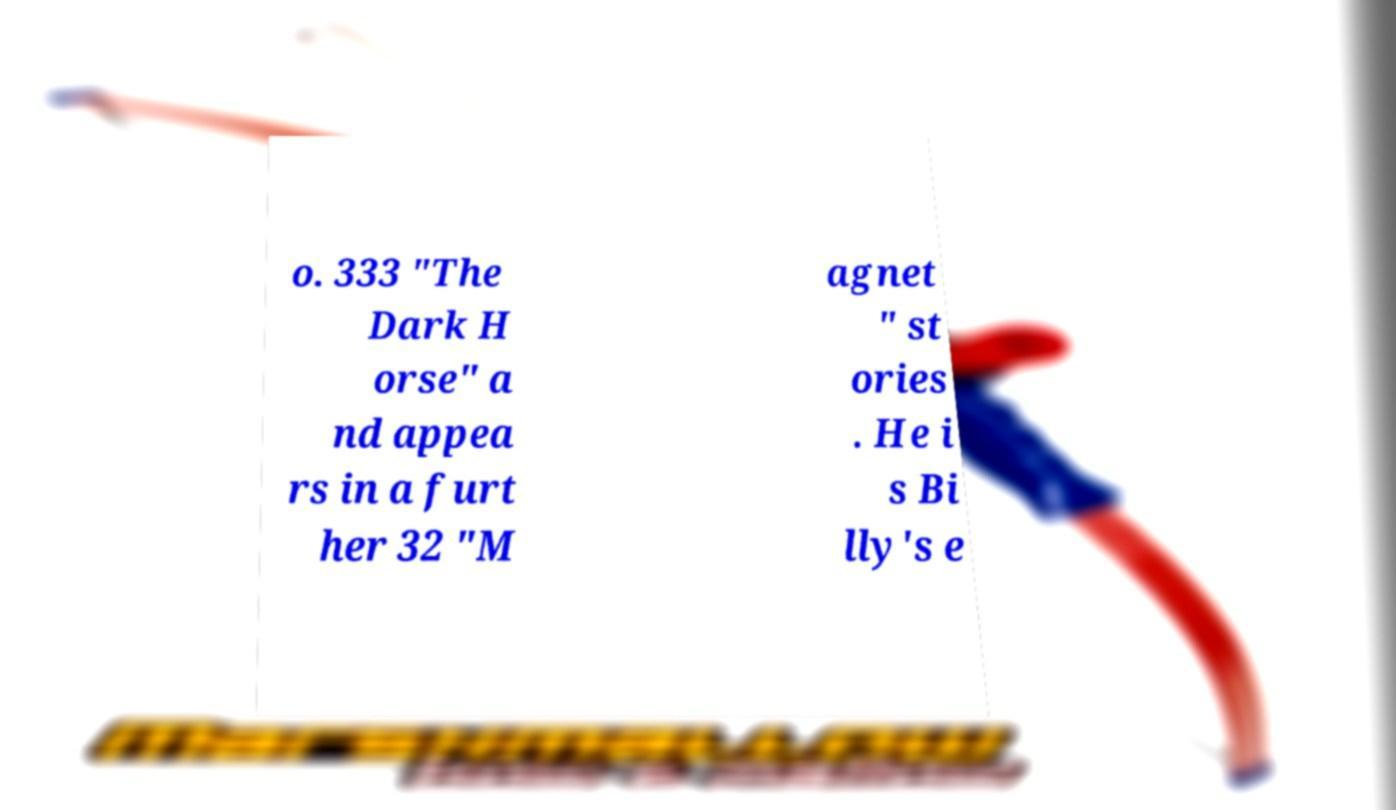Could you assist in decoding the text presented in this image and type it out clearly? o. 333 "The Dark H orse" a nd appea rs in a furt her 32 "M agnet " st ories . He i s Bi lly's e 